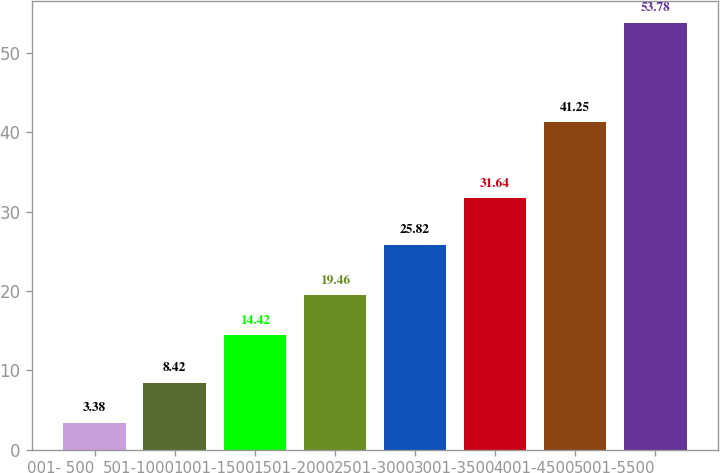Convert chart. <chart><loc_0><loc_0><loc_500><loc_500><bar_chart><fcel>001- 500<fcel>501-1000<fcel>1001-1500<fcel>1501-2000<fcel>2501-3000<fcel>3001-3500<fcel>4001-4500<fcel>5001-5500<nl><fcel>3.38<fcel>8.42<fcel>14.42<fcel>19.46<fcel>25.82<fcel>31.64<fcel>41.25<fcel>53.78<nl></chart> 